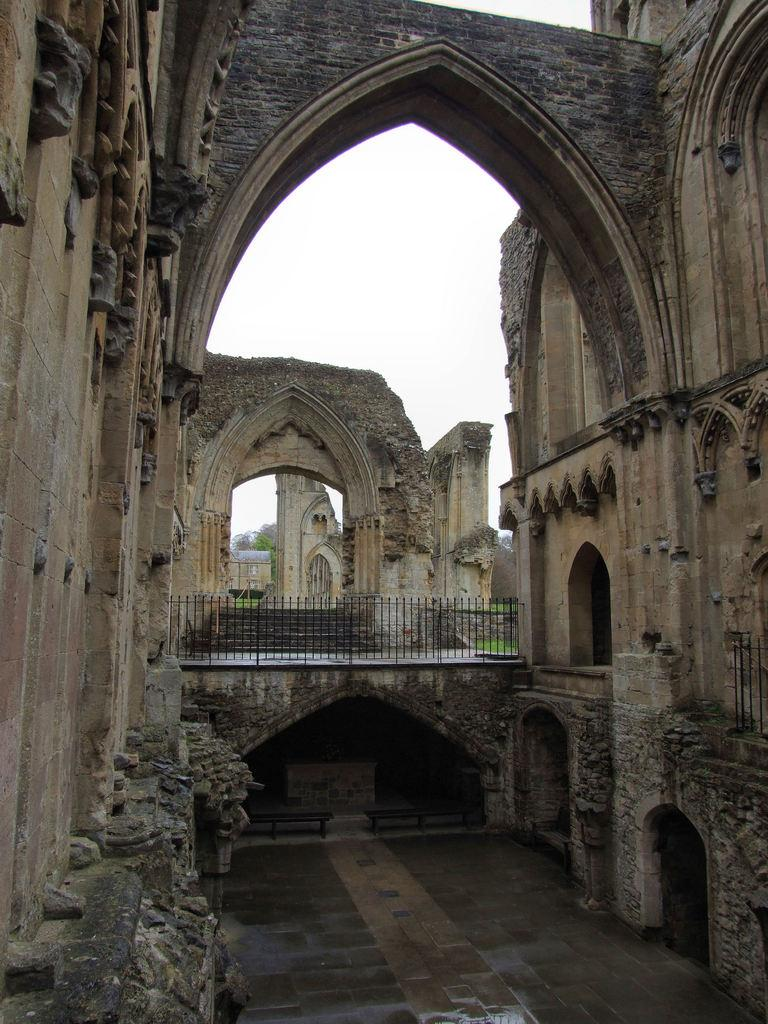What type of structure is present in the image? There is a building in the image. What can be seen in the middle of the image? There is a railing in the middle of the image. What is visible at the top of the image? The sky is visible at the top of the image. What type of bread can be seen growing near the building in the image? There is no bread present in the image, and bread does not grow like plants. 